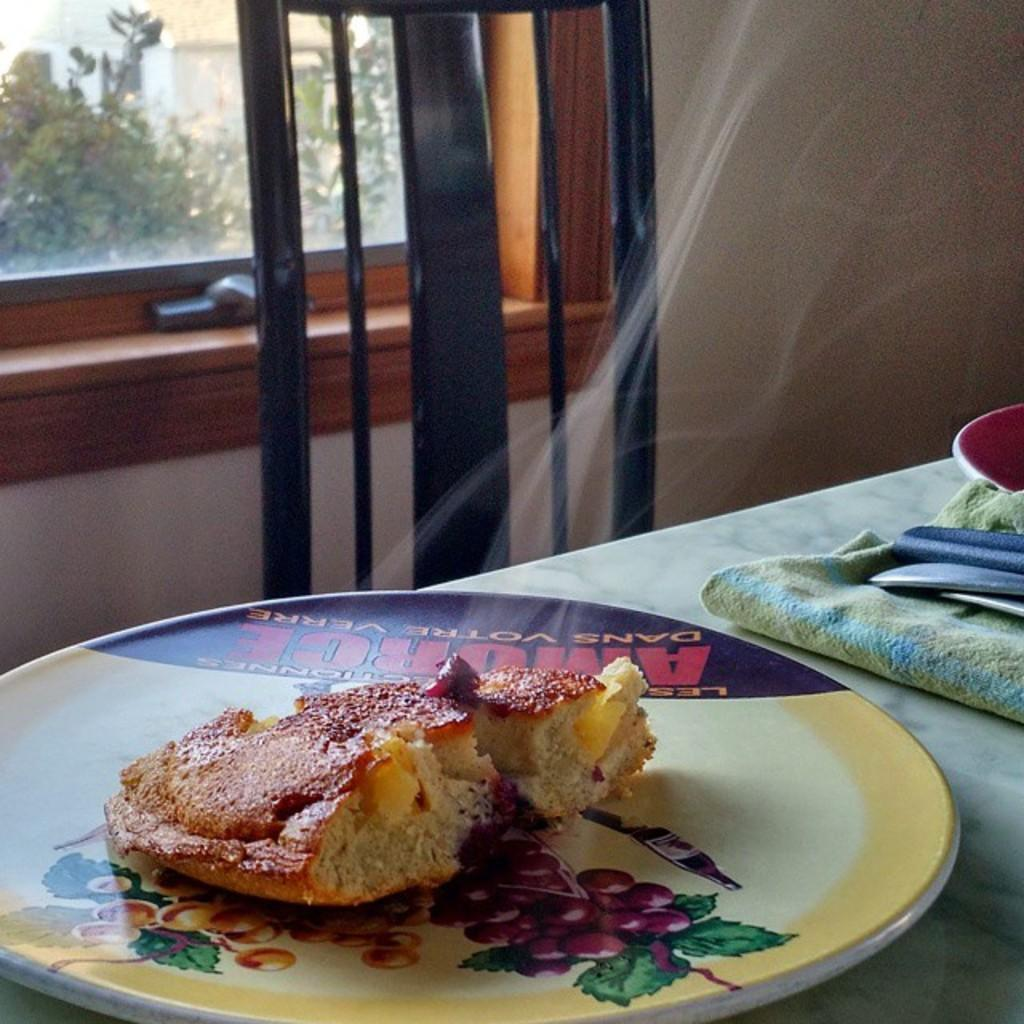What is on the plate in the image? There is food in a plate in the image. What else can be seen in the image besides the plate? There is a cloth, objects on a platform, a chair, a wall, and a window in the background of the image. Trees are visible through the window. What type of scent can be smelled coming from the bell in the image? There is no bell present in the image, so it is not possible to determine what scent might be associated with it. 